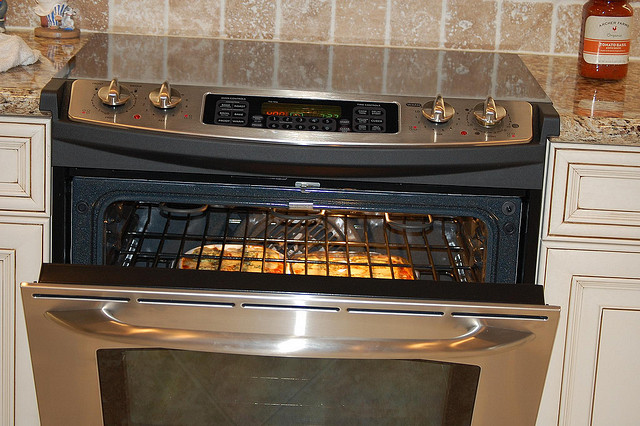<image>What kind of food is in the jar on the counter? I don't know what kind of food is in the jar on the counter. It could be pasta sauce, tomato sauce, pizza, or some other type of sauce. What kind of food is in the jar on the counter? I am not sure what kind of food is in the jar on the counter. It can be seen as pasta sauce, tomato sauce, pizza sauce or condiment. 